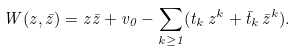<formula> <loc_0><loc_0><loc_500><loc_500>W ( z , \bar { z } ) = z \bar { z } + v _ { 0 } - \sum _ { k \geq 1 } ( t _ { k } \, z ^ { k } + \bar { t } _ { k } \, \bar { z } ^ { k } ) .</formula> 